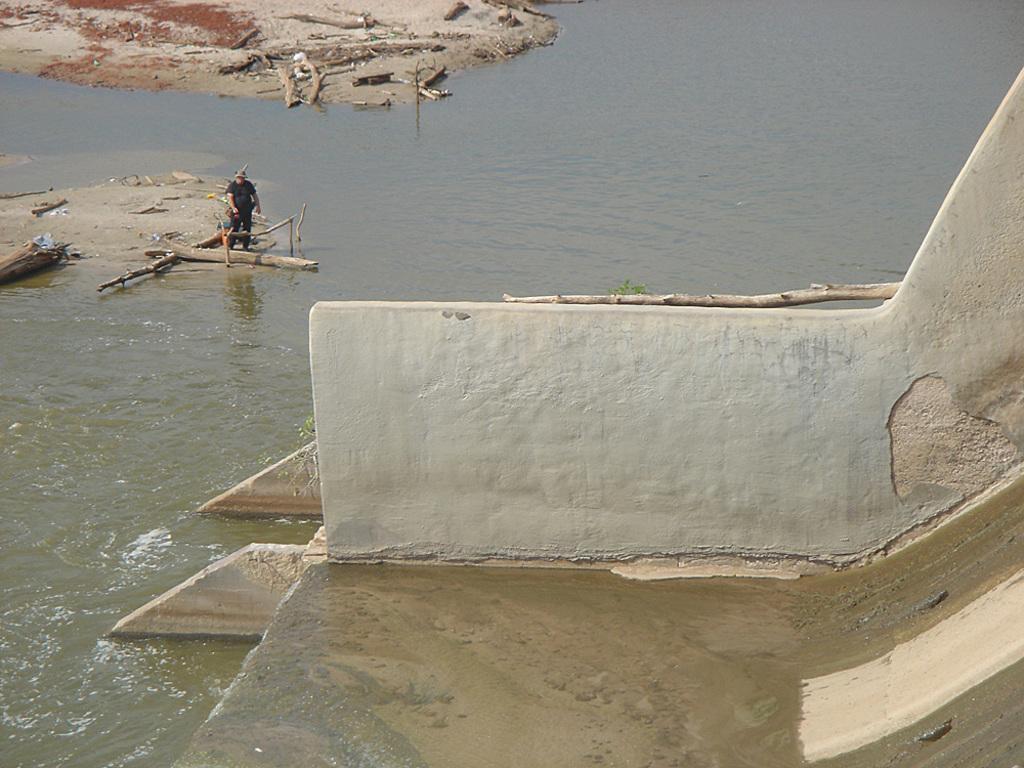How would you summarize this image in a sentence or two? In this picture we can see a slide, wall, beside this wall we can see water, person standing and some sticks. 